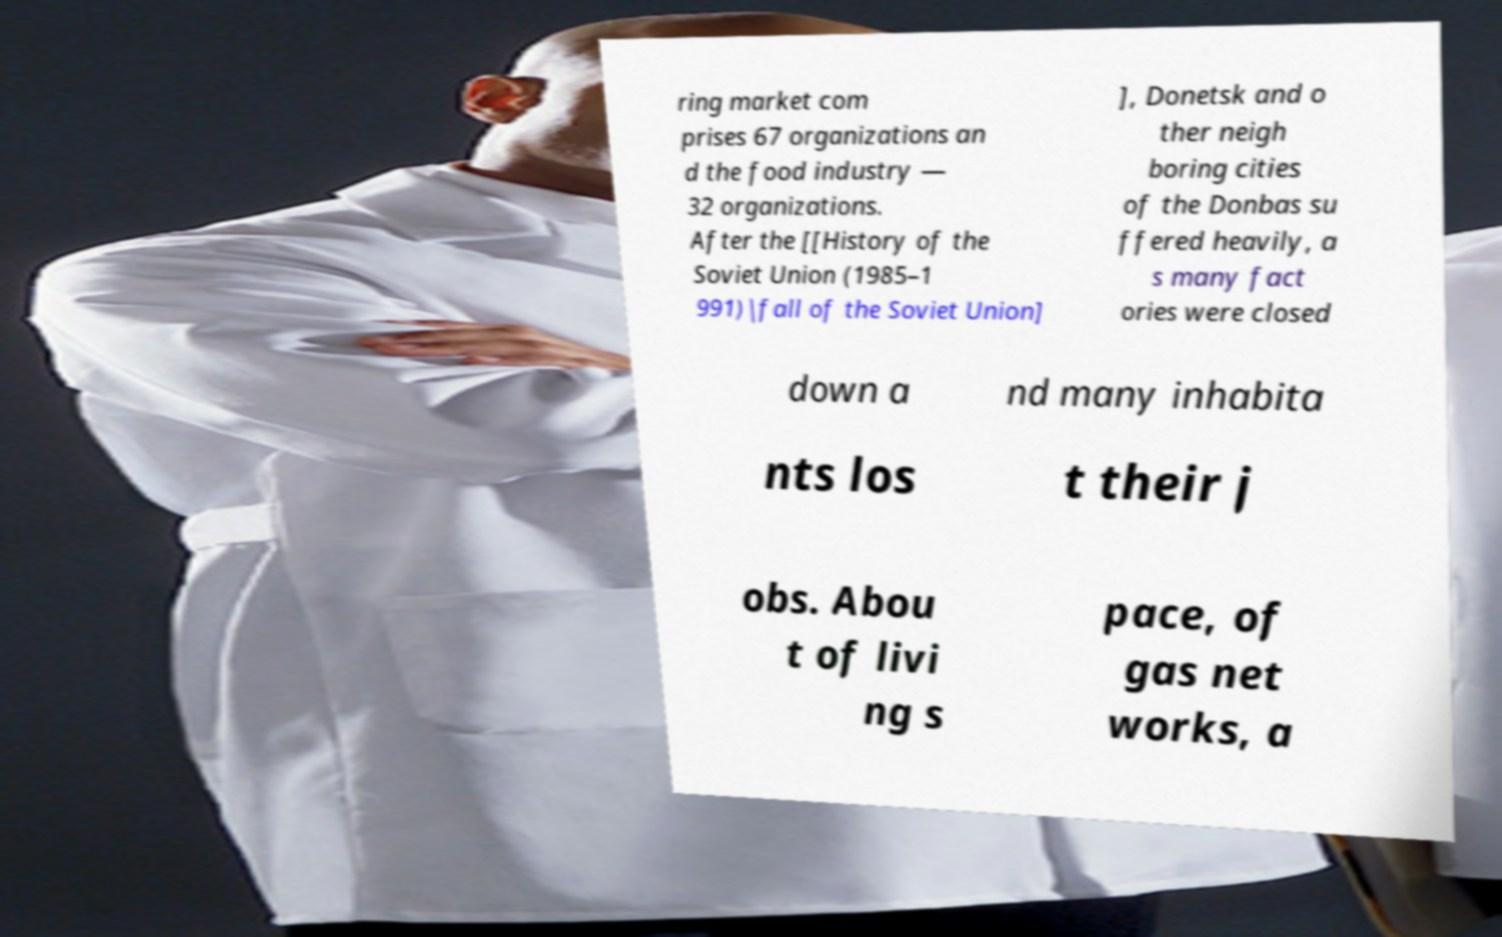For documentation purposes, I need the text within this image transcribed. Could you provide that? ring market com prises 67 organizations an d the food industry — 32 organizations. After the [[History of the Soviet Union (1985–1 991)|fall of the Soviet Union] ], Donetsk and o ther neigh boring cities of the Donbas su ffered heavily, a s many fact ories were closed down a nd many inhabita nts los t their j obs. Abou t of livi ng s pace, of gas net works, a 